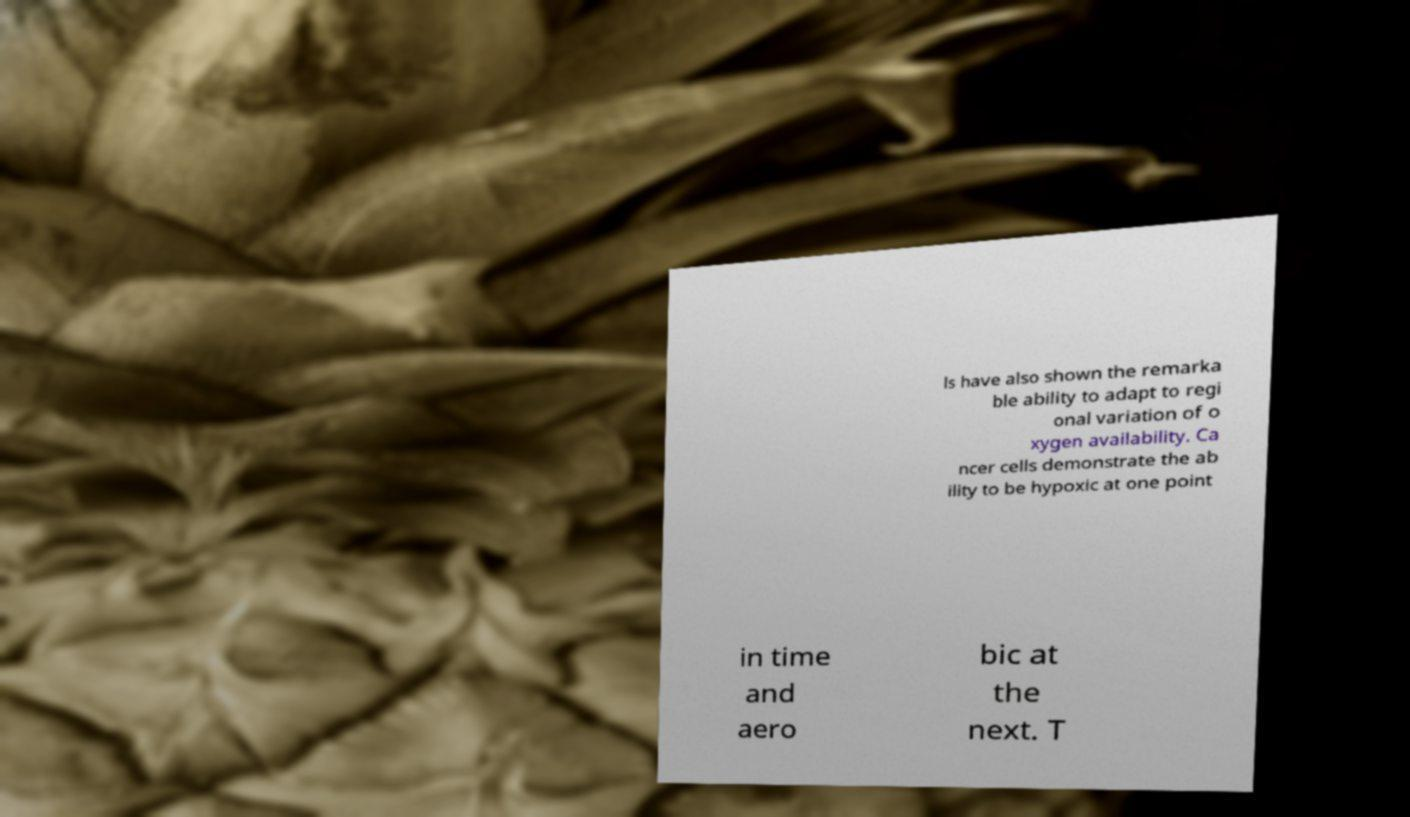What messages or text are displayed in this image? I need them in a readable, typed format. ls have also shown the remarka ble ability to adapt to regi onal variation of o xygen availability. Ca ncer cells demonstrate the ab ility to be hypoxic at one point in time and aero bic at the next. T 